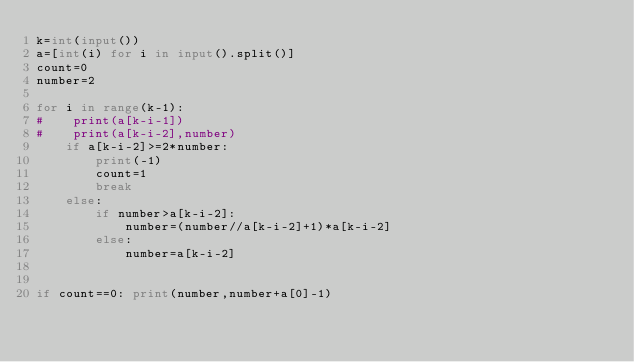Convert code to text. <code><loc_0><loc_0><loc_500><loc_500><_Python_>k=int(input())
a=[int(i) for i in input().split()]
count=0
number=2

for i in range(k-1):
#    print(a[k-i-1])
#    print(a[k-i-2],number)  
    if a[k-i-2]>=2*number:
        print(-1)
        count=1
        break
    else:
        if number>a[k-i-2]:
            number=(number//a[k-i-2]+1)*a[k-i-2]
        else:
            number=a[k-i-2]


if count==0: print(number,number+a[0]-1)




</code> 